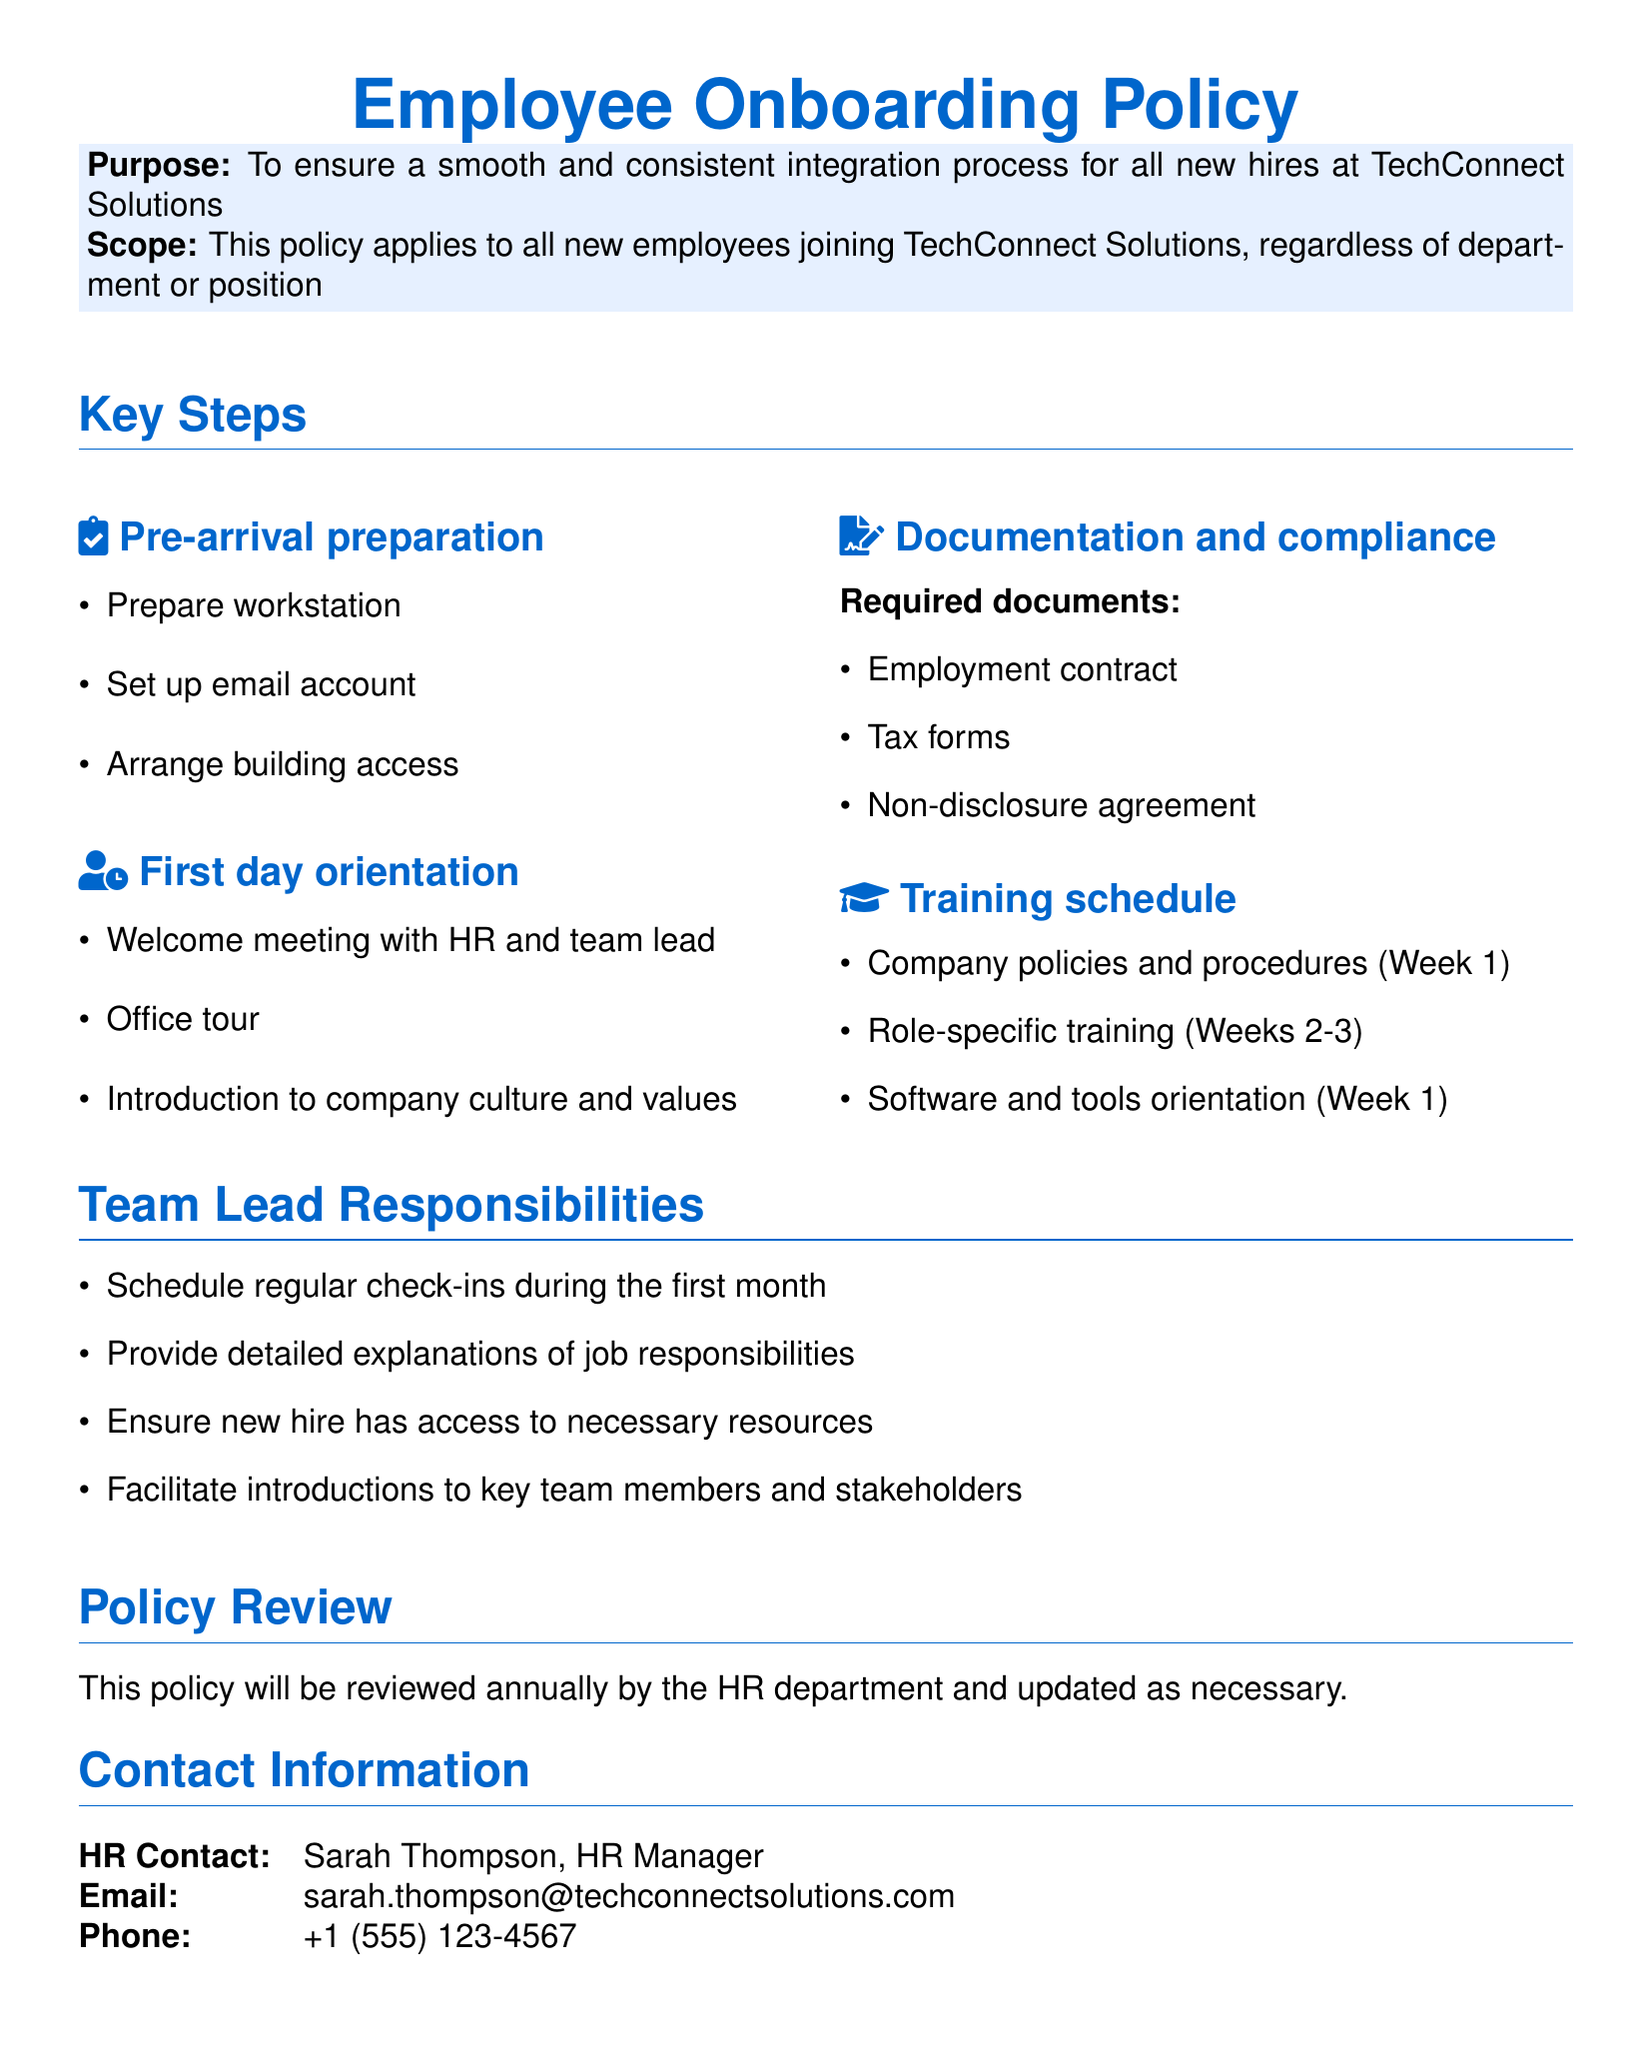What is the purpose of the Employee Onboarding Policy? The purpose is to ensure a smooth and consistent integration process for all new hires at TechConnect Solutions.
Answer: To ensure a smooth and consistent integration process for all new hires at TechConnect Solutions Who is the HR contact listed in the document? The document specifies the HR contact responsible for inquiries related to employee onboarding.
Answer: Sarah Thompson What are the required documents for new hires? The document includes a list of essential documents that new hires need to submit.
Answer: Employment contract, Tax forms, Non-disclosure agreement During which week is the company policies and procedures training scheduled? The training schedule provided indicates when new employees will learn about company policies and procedures.
Answer: Week 1 How many responsibilities are listed for the team lead? The document outlines specific responsibilities that fall under the purview of the team lead regarding onboarding.
Answer: Four What is the timeframe for role-specific training? The policy specifies the duration allocated for role-specific training in the onboarding process.
Answer: Weeks 2-3 How often should the team lead schedule check-ins during the first month? The document mentions the frequency of the team lead's check-ins with new hires during their initial month.
Answer: Regularly Who will review the policy, and how often? The document states who is responsible for the policy review and its frequency.
Answer: Annually by the HR department 